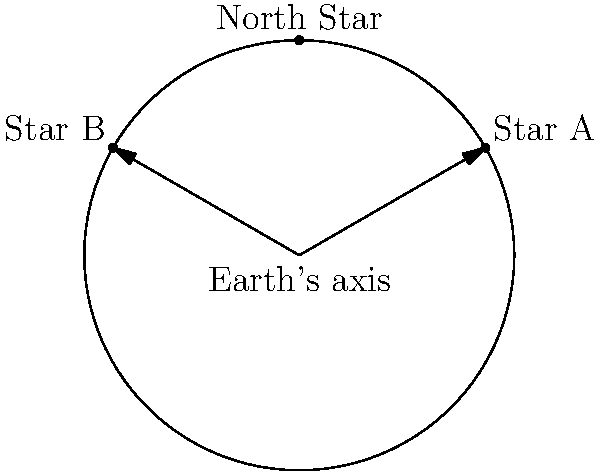Consider the diagram showing the apparent motion of stars in the night sky as seen from the Northern Hemisphere. Star A and Star B are equidistant from the North Star. If Earth completes one full rotation in 24 hours, how long will it take for Star A to appear to move to the position of Star B? To solve this problem, let's follow these steps:

1. Understand the diagram:
   - The circle represents the path of stars' apparent motion.
   - The North Star is at the center of rotation.
   - Stars A and B are equidistant from the North Star.

2. Analyze the angular displacement:
   - The angle between Star A and Star B is 120° (2π/3 radians).
   - This is because they form an equilateral triangle with the center.

3. Calculate the proportion of a full rotation:
   - A full rotation is 360° (2π radians).
   - The proportion of rotation from A to B is:
     $\frac{120°}{360°} = \frac{1}{3}$

4. Apply this proportion to Earth's rotation period:
   - Earth rotates once in 24 hours.
   - Time for Star A to reach Star B's position:
     $24 \text{ hours} \times \frac{1}{3} = 8 \text{ hours}$

Therefore, it will take 8 hours for Star A to appear to move to the position of Star B.
Answer: 8 hours 